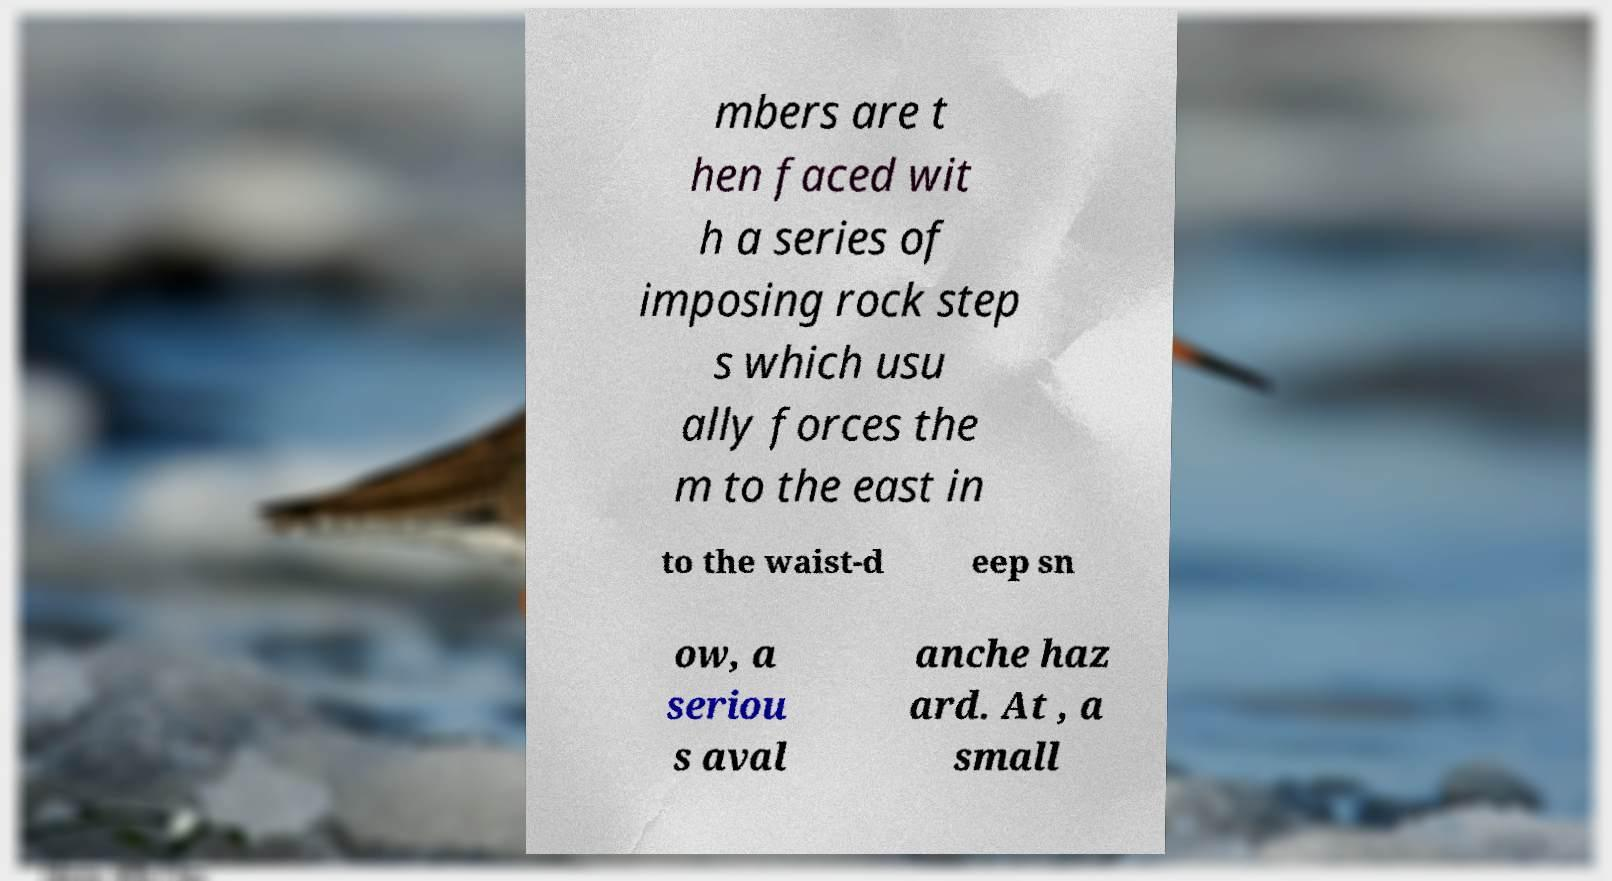Can you read and provide the text displayed in the image?This photo seems to have some interesting text. Can you extract and type it out for me? mbers are t hen faced wit h a series of imposing rock step s which usu ally forces the m to the east in to the waist-d eep sn ow, a seriou s aval anche haz ard. At , a small 